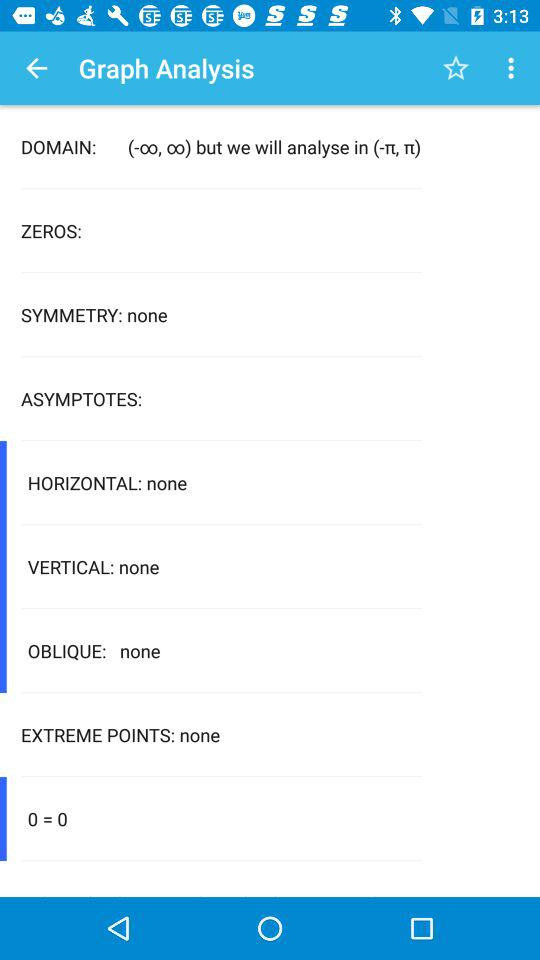What is mentioned in the domain? In the domain, "(-∞, ∞) but we will analyse in (-π, π)" is mentioned. 